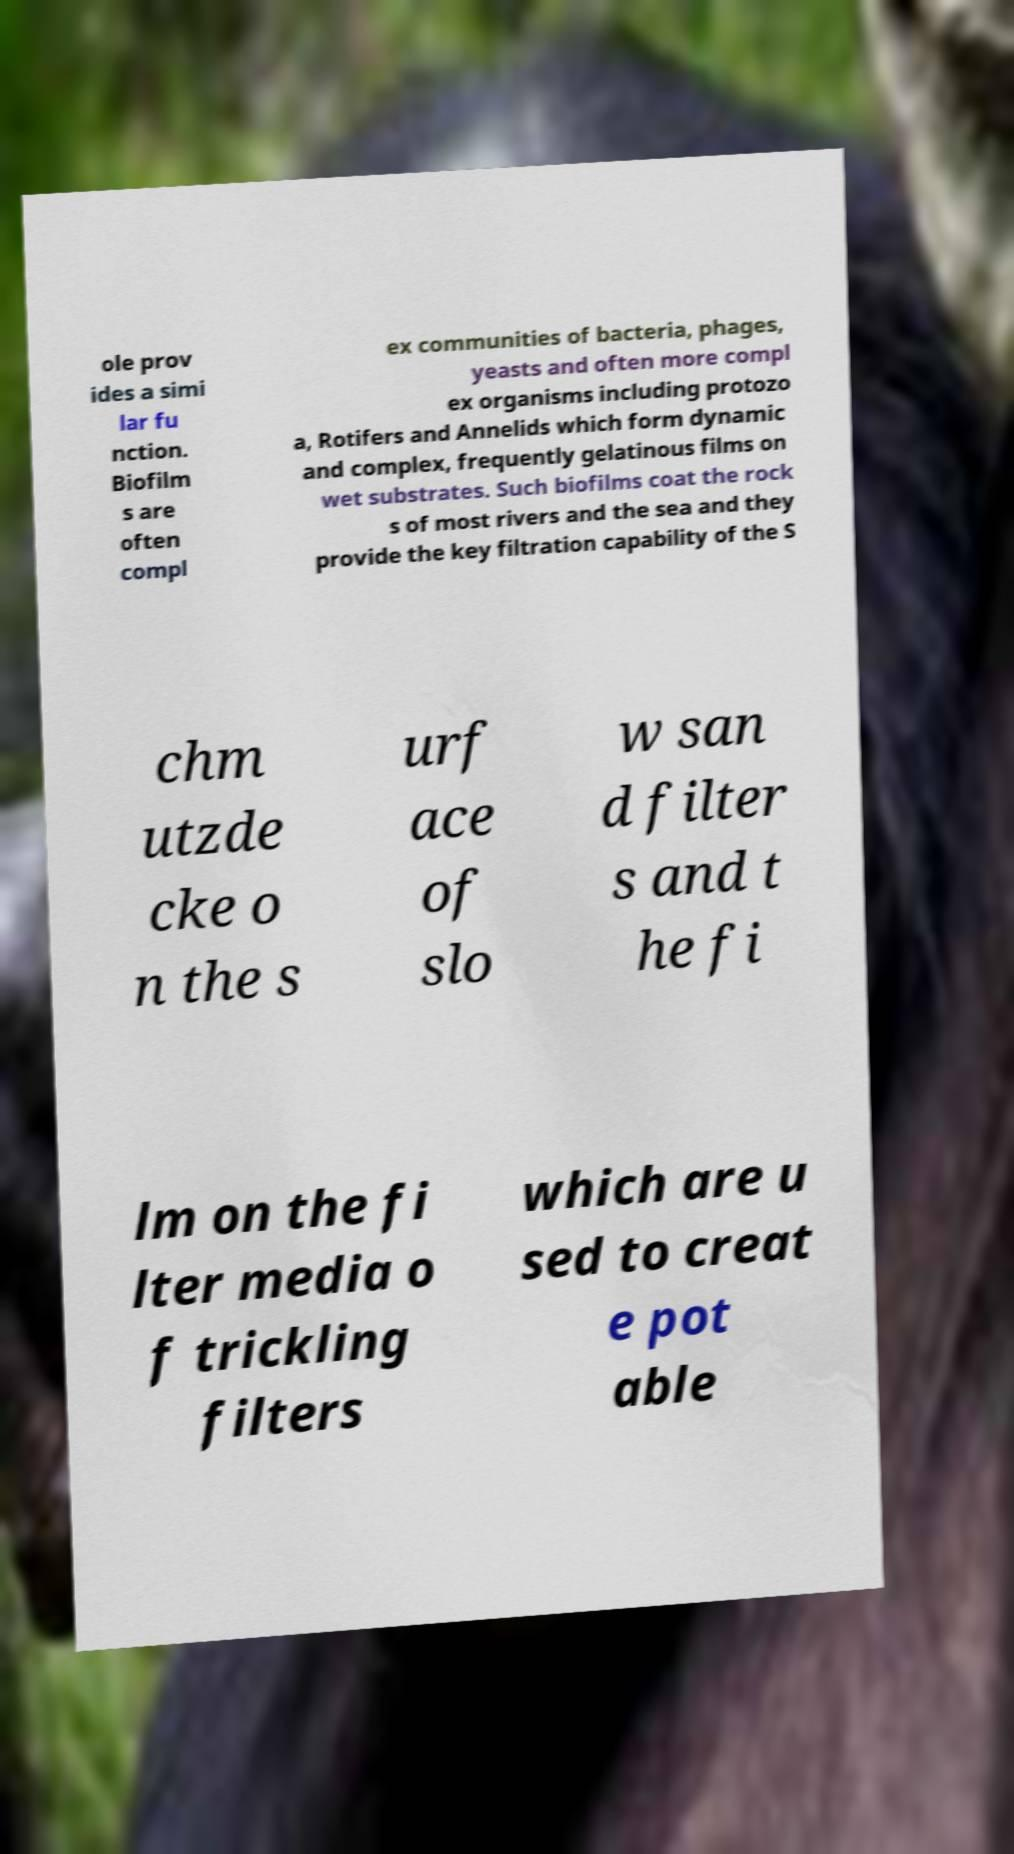Please read and relay the text visible in this image. What does it say? ole prov ides a simi lar fu nction. Biofilm s are often compl ex communities of bacteria, phages, yeasts and often more compl ex organisms including protozo a, Rotifers and Annelids which form dynamic and complex, frequently gelatinous films on wet substrates. Such biofilms coat the rock s of most rivers and the sea and they provide the key filtration capability of the S chm utzde cke o n the s urf ace of slo w san d filter s and t he fi lm on the fi lter media o f trickling filters which are u sed to creat e pot able 